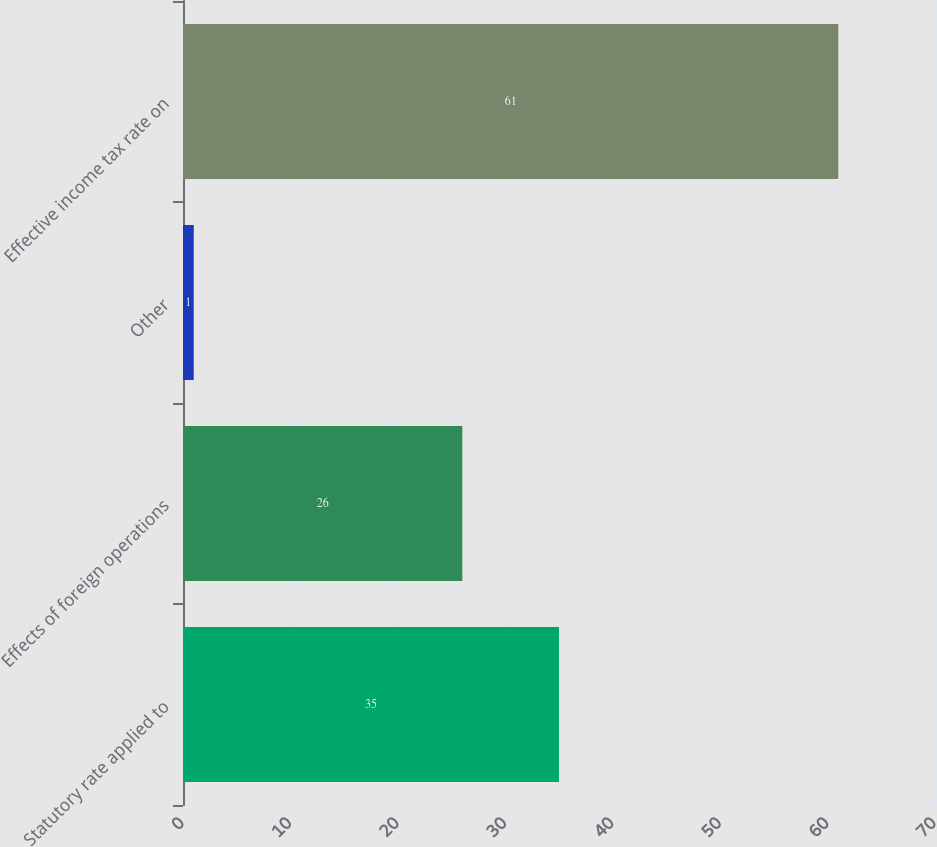Convert chart to OTSL. <chart><loc_0><loc_0><loc_500><loc_500><bar_chart><fcel>Statutory rate applied to<fcel>Effects of foreign operations<fcel>Other<fcel>Effective income tax rate on<nl><fcel>35<fcel>26<fcel>1<fcel>61<nl></chart> 